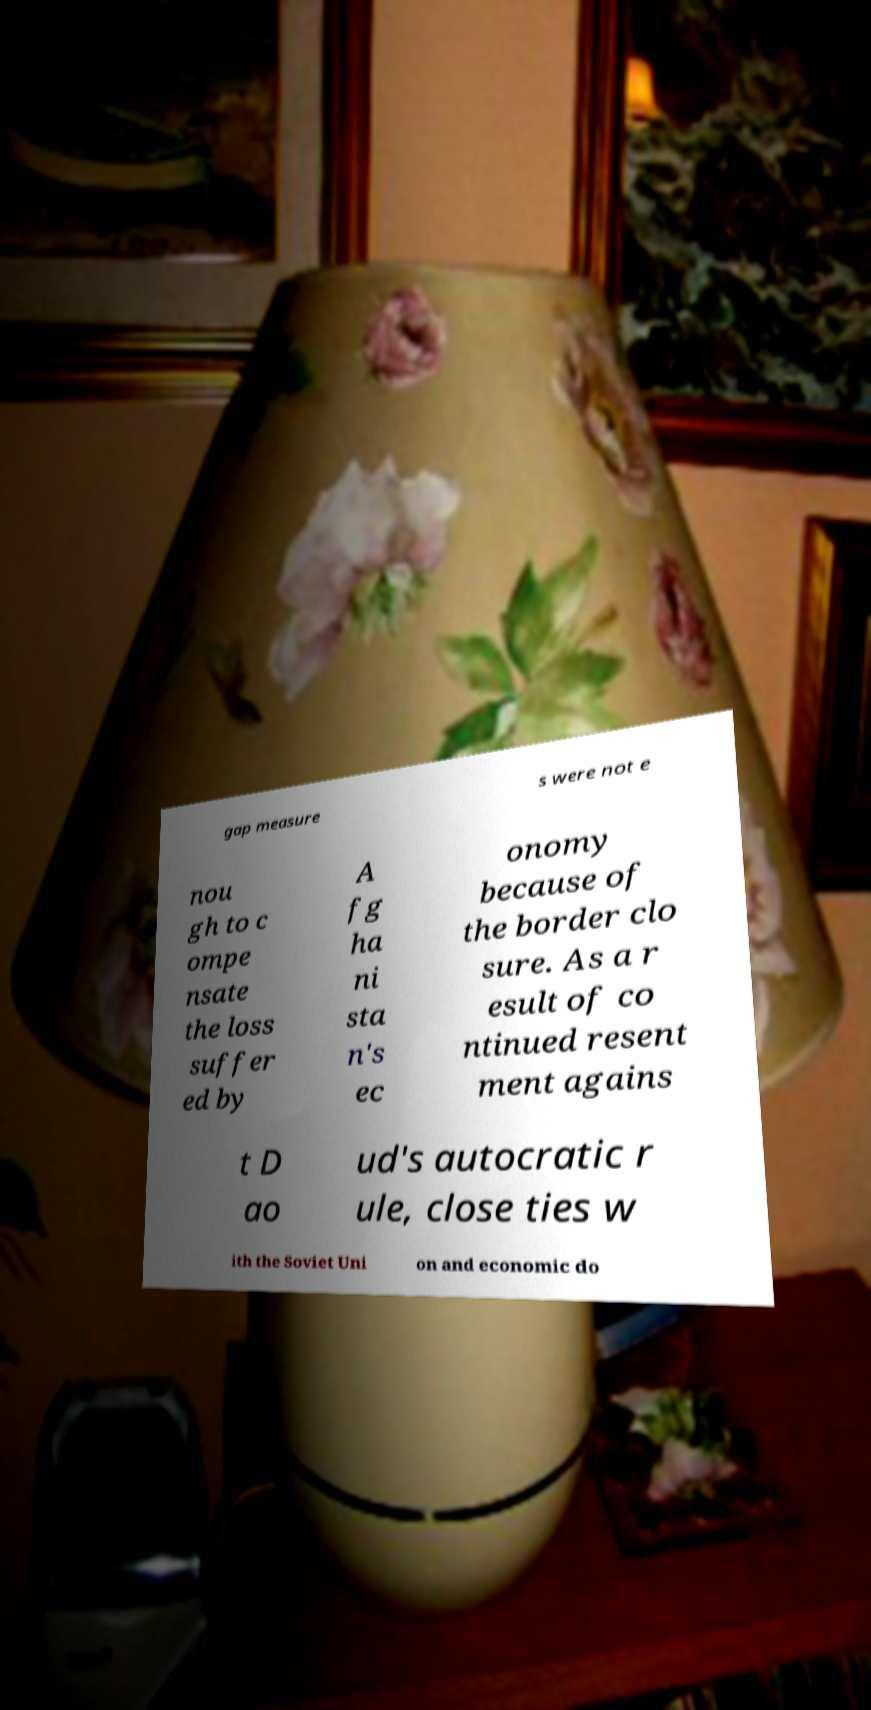Please read and relay the text visible in this image. What does it say? gap measure s were not e nou gh to c ompe nsate the loss suffer ed by A fg ha ni sta n's ec onomy because of the border clo sure. As a r esult of co ntinued resent ment agains t D ao ud's autocratic r ule, close ties w ith the Soviet Uni on and economic do 